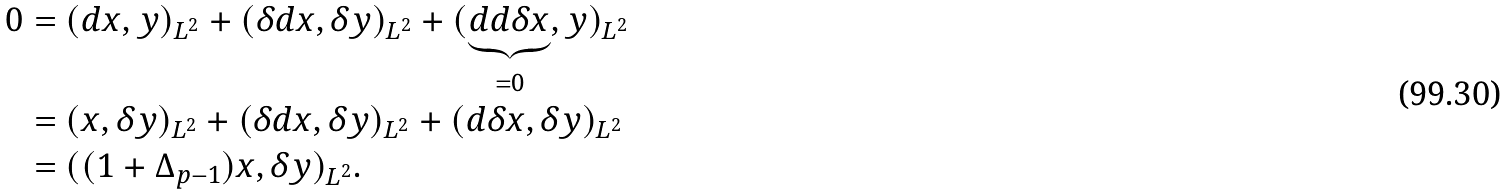<formula> <loc_0><loc_0><loc_500><loc_500>0 & = ( d x , y ) _ { L ^ { 2 } } + ( \delta d x , \delta y ) _ { L ^ { 2 } } + ( \underbrace { d d \delta x } _ { = 0 } , y ) _ { L ^ { 2 } } \\ \ & = ( x , \delta y ) _ { L ^ { 2 } } + ( \delta d x , \delta y ) _ { L ^ { 2 } } + ( d \delta x , \delta y ) _ { L ^ { 2 } } \\ & = ( ( 1 + \Delta _ { p - 1 } ) x , \delta y ) _ { L ^ { 2 } } .</formula> 